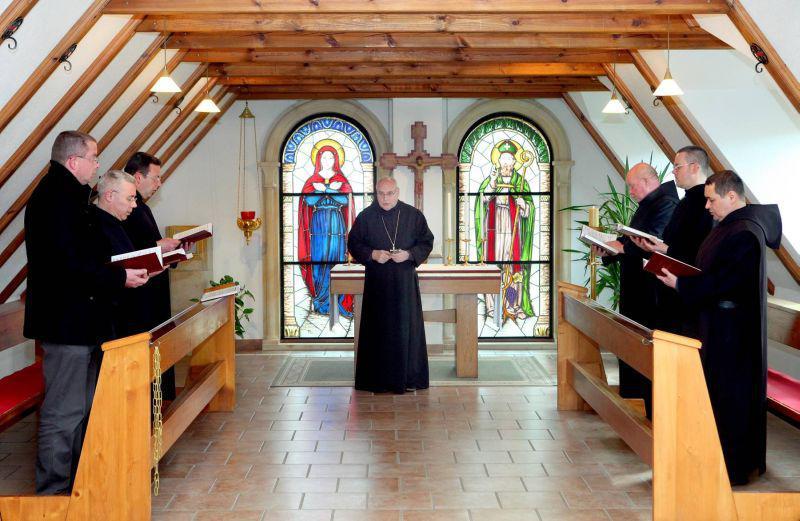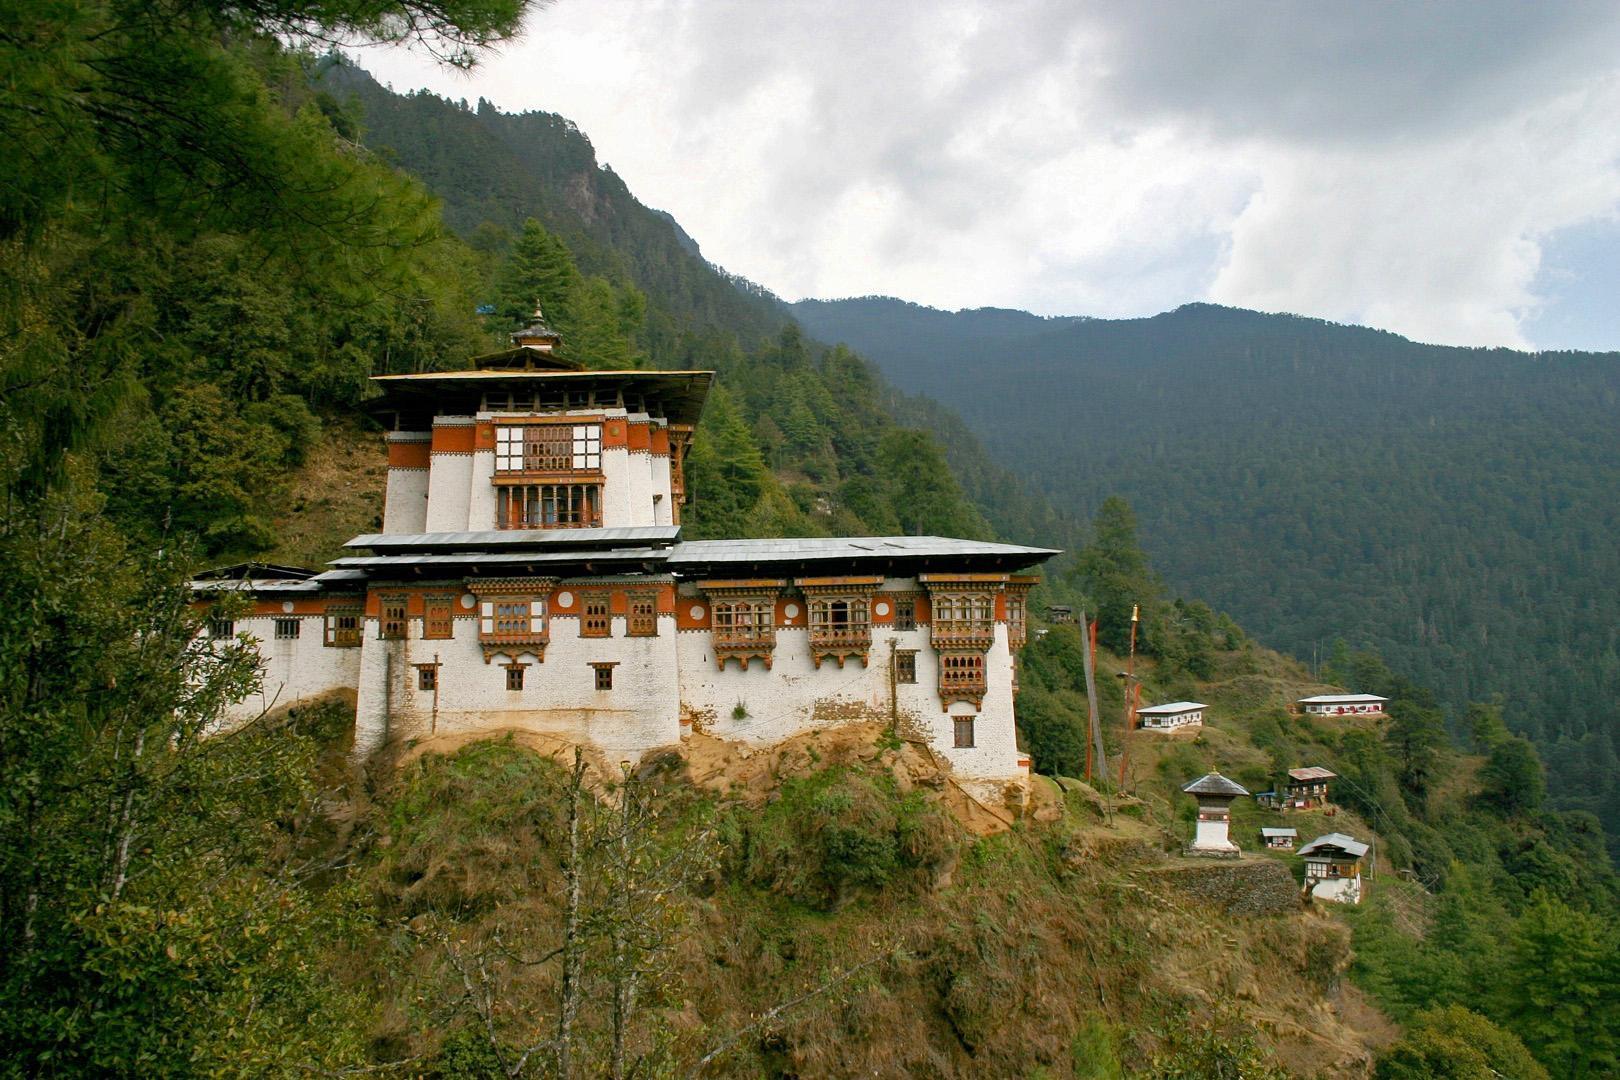The first image is the image on the left, the second image is the image on the right. Considering the images on both sides, is "A bell tower is visible in at least one image." valid? Answer yes or no. No. 